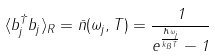Convert formula to latex. <formula><loc_0><loc_0><loc_500><loc_500>\langle b _ { j } ^ { \dag } b _ { j } \rangle _ { R } = \bar { n } ( \omega _ { j } , T ) = \frac { 1 } { e ^ { \frac { \hbar { \omega } _ { j } } { k _ { B } T } } - 1 }</formula> 